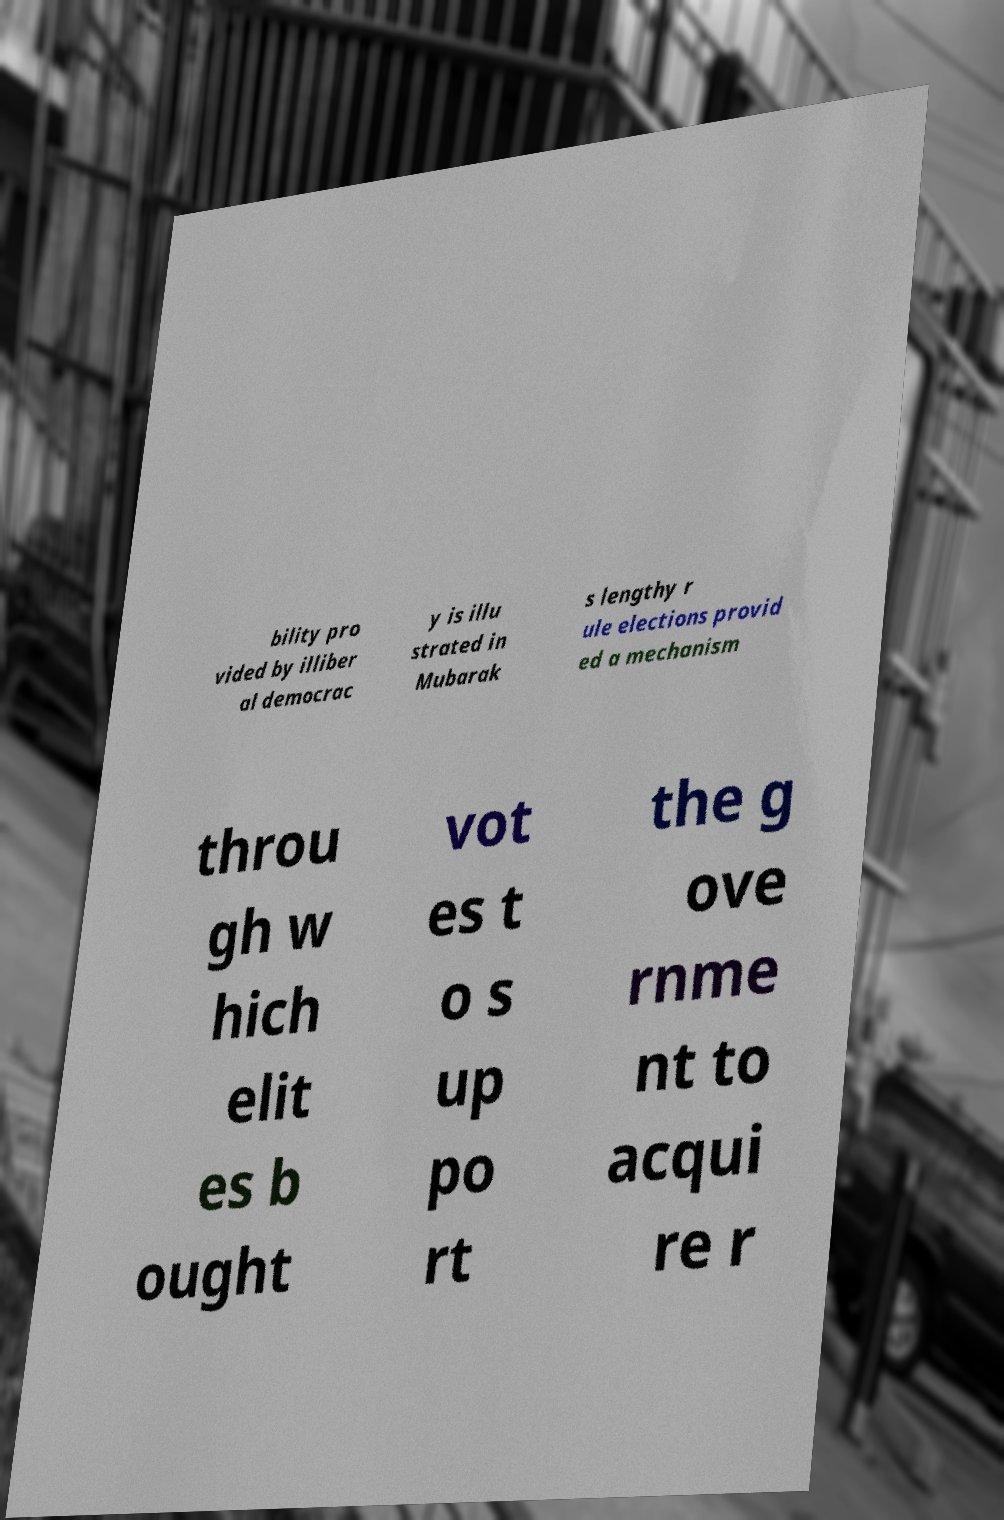For documentation purposes, I need the text within this image transcribed. Could you provide that? bility pro vided by illiber al democrac y is illu strated in Mubarak s lengthy r ule elections provid ed a mechanism throu gh w hich elit es b ought vot es t o s up po rt the g ove rnme nt to acqui re r 